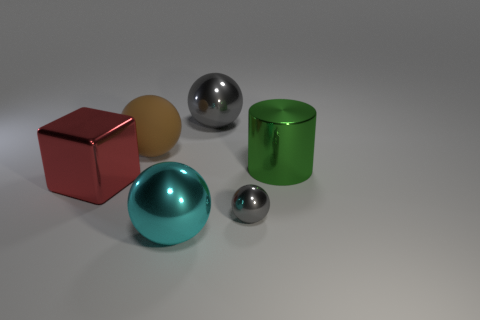There is a gray shiny ball to the left of the small shiny object; is there a brown rubber thing on the right side of it?
Provide a succinct answer. No. There is a big sphere in front of the tiny shiny object; is it the same color as the big shiny object on the right side of the tiny shiny sphere?
Offer a very short reply. No. The tiny object has what color?
Offer a very short reply. Gray. Is there any other thing of the same color as the matte ball?
Provide a succinct answer. No. There is a shiny sphere that is both to the left of the tiny metal thing and in front of the cylinder; what color is it?
Provide a short and direct response. Cyan. Do the ball to the left of the cyan object and the big gray thing have the same size?
Ensure brevity in your answer.  Yes. Is the number of big red things that are behind the block greater than the number of big red blocks?
Provide a succinct answer. No. Is the brown object the same shape as the cyan thing?
Your answer should be compact. Yes. How big is the red metallic block?
Provide a succinct answer. Large. Is the number of big cyan objects right of the cylinder greater than the number of big gray things to the left of the rubber ball?
Ensure brevity in your answer.  No. 